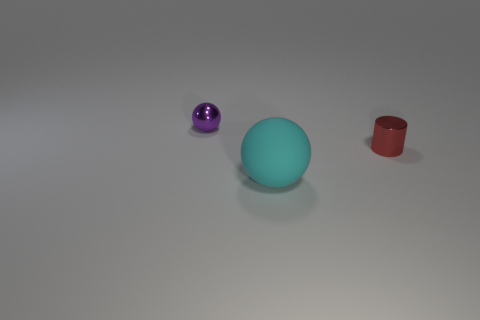Is there anything else that is the same material as the large ball?
Your answer should be compact. No. There is a thing that is in front of the purple metal thing and behind the big matte sphere; what is its shape?
Offer a terse response. Cylinder. What size is the other metal object that is the same shape as the cyan object?
Keep it short and to the point. Small. Are there fewer rubber balls that are behind the tiny red thing than large red things?
Give a very brief answer. No. There is a shiny thing to the left of the tiny red cylinder; how big is it?
Your answer should be compact. Small. There is a small object that is the same shape as the big cyan matte thing; what color is it?
Give a very brief answer. Purple. How many other spheres have the same color as the metal ball?
Ensure brevity in your answer.  0. Are there any other things that are the same shape as the large rubber thing?
Provide a succinct answer. Yes. Are there any cyan matte balls to the right of the big rubber sphere that is right of the small thing that is behind the tiny red object?
Your answer should be compact. No. What number of big balls have the same material as the cyan object?
Provide a succinct answer. 0. 